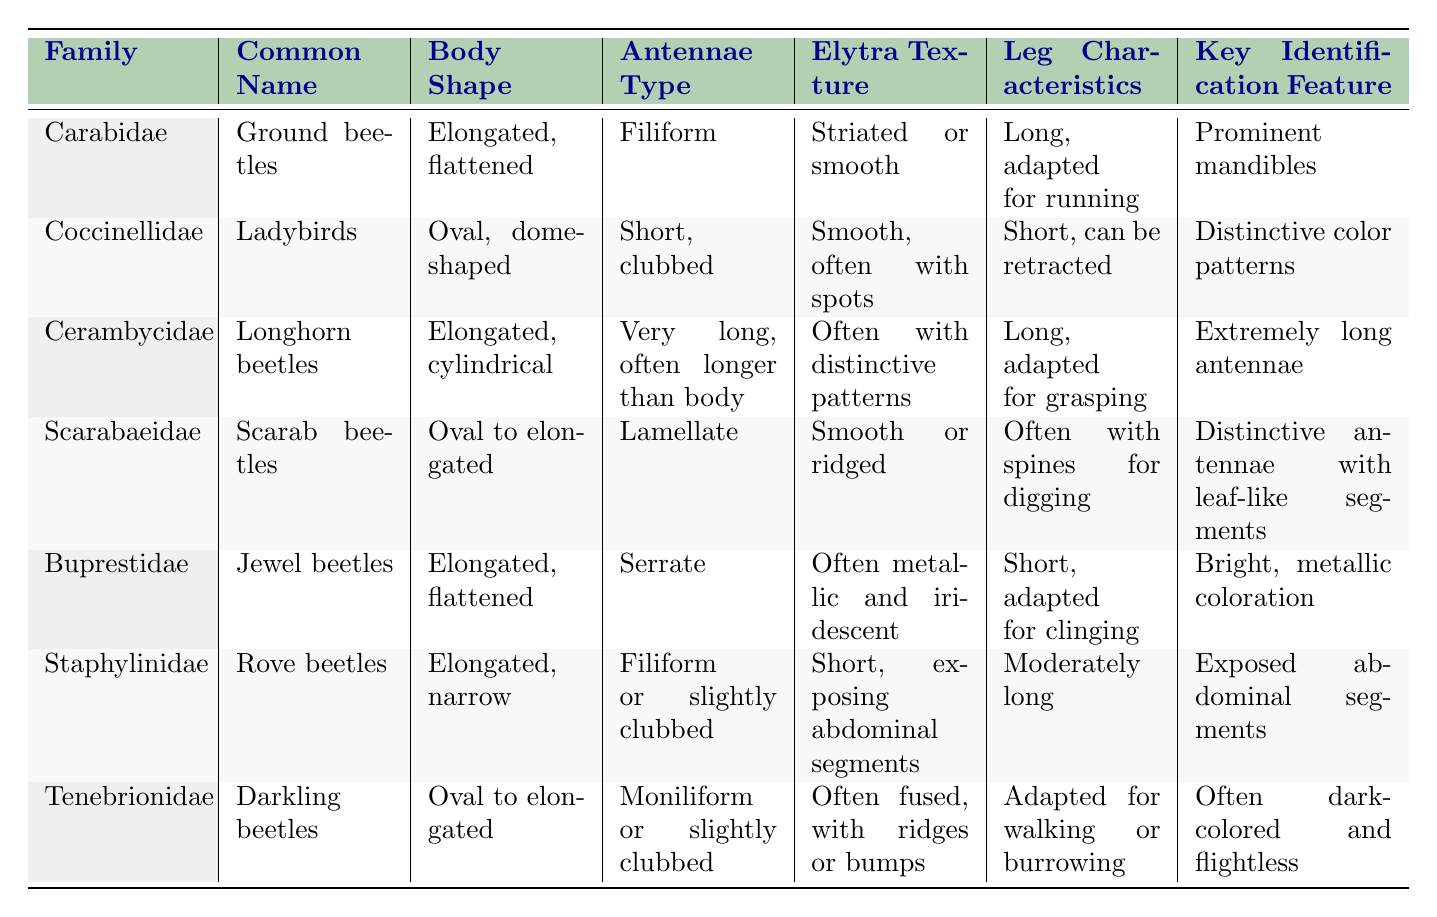What is the common name for the family Carabidae? The family Carabidae is listed in the table with its common name. Referring to the table, it shows that Carabidae corresponds to Ground beetles.
Answer: Ground beetles Which beetle family has a body shape described as oval to elongated? The table lists various beetle families along with their body shapes. By scanning the table, I find that both the Scarabaeidae and Tenebrionidae families have an oval to elongated body shape.
Answer: Scarabaeidae and Tenebrionidae What is the key identification feature of Coccinellidae? Looking at the table, the row for Coccinellidae specifies that its key identification feature is distinctive color patterns.
Answer: Distinctive color patterns Does the Cerambycidae family have very long antennae? The table states that the antennae type for Cerambycidae is very long and often longer than the body. Therefore, the answer is yes.
Answer: Yes Which family is characterized by bright, metallic coloration? In the table, the Buprestidae family is specifically noted for its bright, metallic coloration in the key identification feature column.
Answer: Buprestidae How many families have a body shape that is elongated? The table lists several families with their corresponding body shapes. Scanning through, Carabidae, Cerambycidae, Buprestidae, and Staphylinidae are noted as having an elongated body shape. Therefore, there are 4 families in total.
Answer: 4 What type of antennae do Scarabaeidae beetles have? The table describes the antennae type for Scarabaeidae as lamellate. This information can be directly retrieved from the table.
Answer: Lamellate Which beetle families have long legs adapted for running or grasping? Referring to the leg characteristics column in the table, Carabidae has long legs adapted for running, while Cerambycidae has long legs adapted for grasping. These are the two families that fit this description.
Answer: Carabidae and Cerambycidae Is it true that all families listed have some smooth elytra texture? To answer this, I look at the elytra texture descriptions in the table. While some families like Coccinellidae and Scarabaeidae have smooth textures, others like Cerambycidae, Buprestidae, and Tenebrionidae are noted to have different textures, meaning not all have a smooth texture.
Answer: No Which family has the shortest antennae type? By examining the antennae type for each family in the table, I find that Coccinellidae has the shortest antennae type, categorized as short and clubbed.
Answer: Coccinellidae 